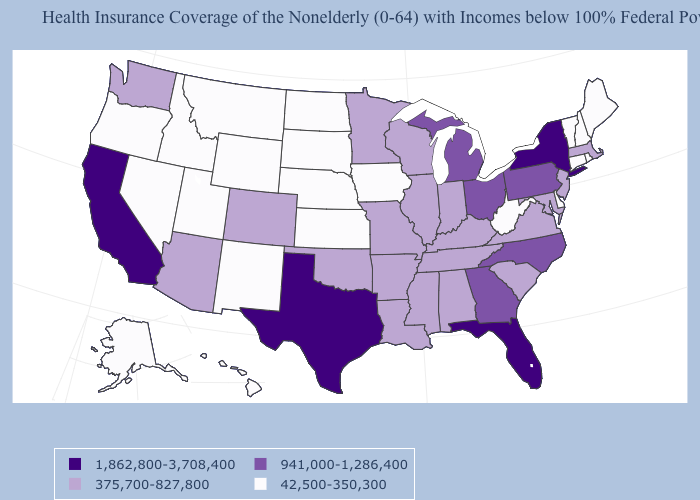Name the states that have a value in the range 375,700-827,800?
Quick response, please. Alabama, Arizona, Arkansas, Colorado, Illinois, Indiana, Kentucky, Louisiana, Maryland, Massachusetts, Minnesota, Mississippi, Missouri, New Jersey, Oklahoma, South Carolina, Tennessee, Virginia, Washington, Wisconsin. What is the lowest value in the West?
Quick response, please. 42,500-350,300. Which states have the lowest value in the MidWest?
Keep it brief. Iowa, Kansas, Nebraska, North Dakota, South Dakota. Among the states that border Wisconsin , which have the lowest value?
Be succinct. Iowa. Name the states that have a value in the range 1,862,800-3,708,400?
Answer briefly. California, Florida, New York, Texas. What is the value of Vermont?
Answer briefly. 42,500-350,300. Does New Hampshire have the same value as Wyoming?
Give a very brief answer. Yes. What is the value of Nevada?
Short answer required. 42,500-350,300. Name the states that have a value in the range 375,700-827,800?
Answer briefly. Alabama, Arizona, Arkansas, Colorado, Illinois, Indiana, Kentucky, Louisiana, Maryland, Massachusetts, Minnesota, Mississippi, Missouri, New Jersey, Oklahoma, South Carolina, Tennessee, Virginia, Washington, Wisconsin. Does the map have missing data?
Quick response, please. No. What is the value of North Dakota?
Write a very short answer. 42,500-350,300. What is the value of North Carolina?
Be succinct. 941,000-1,286,400. Name the states that have a value in the range 42,500-350,300?
Answer briefly. Alaska, Connecticut, Delaware, Hawaii, Idaho, Iowa, Kansas, Maine, Montana, Nebraska, Nevada, New Hampshire, New Mexico, North Dakota, Oregon, Rhode Island, South Dakota, Utah, Vermont, West Virginia, Wyoming. 